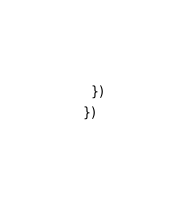Convert code to text. <code><loc_0><loc_0><loc_500><loc_500><_JavaScript_>  })
})
</code> 